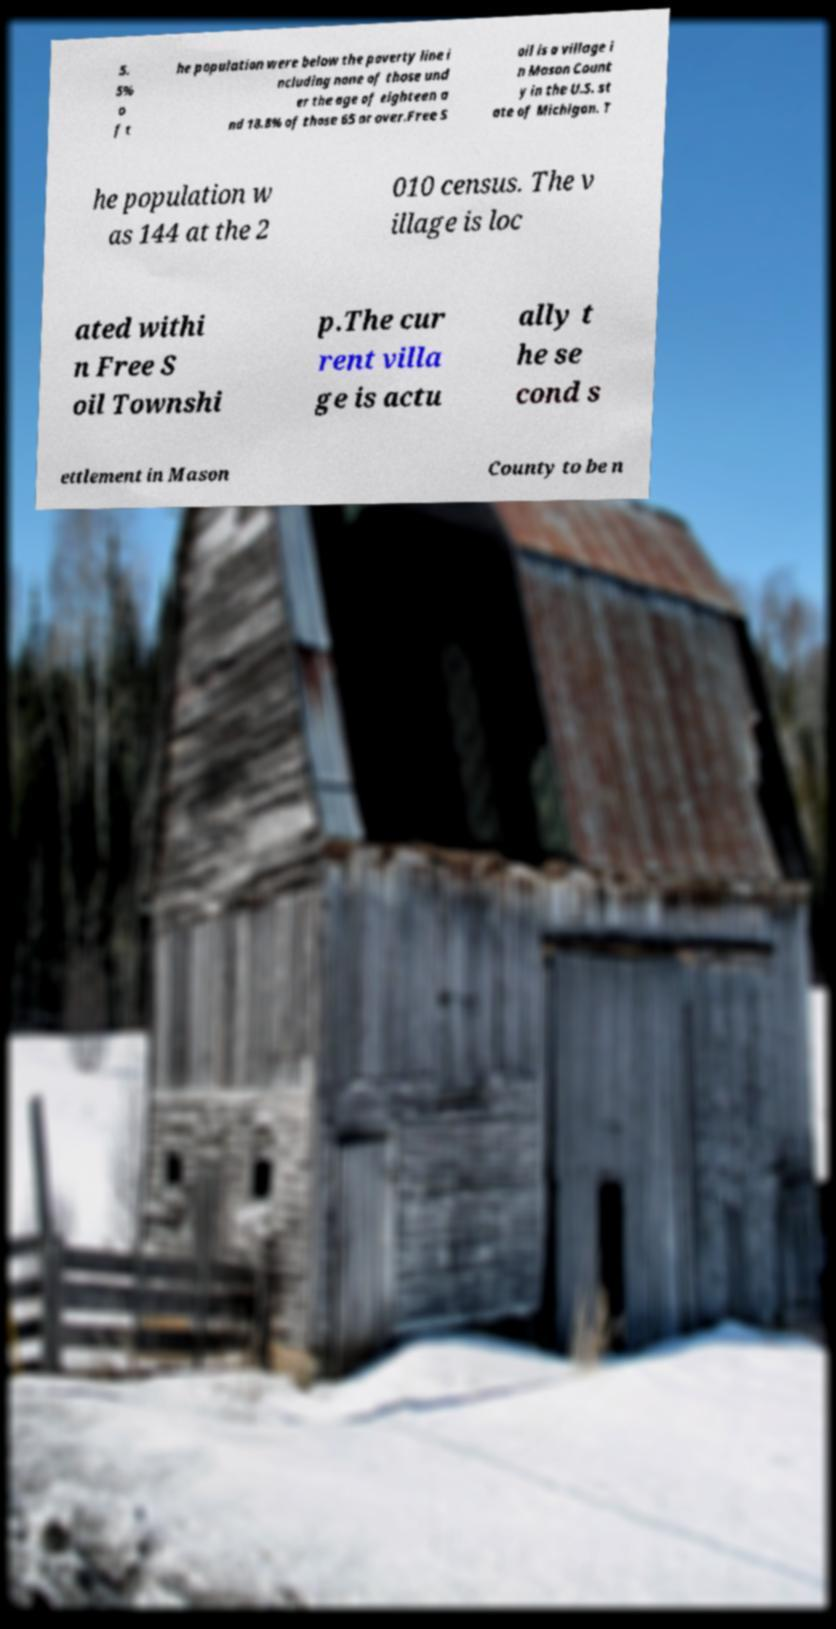I need the written content from this picture converted into text. Can you do that? 5. 5% o f t he population were below the poverty line i ncluding none of those und er the age of eighteen a nd 18.8% of those 65 or over.Free S oil is a village i n Mason Count y in the U.S. st ate of Michigan. T he population w as 144 at the 2 010 census. The v illage is loc ated withi n Free S oil Townshi p.The cur rent villa ge is actu ally t he se cond s ettlement in Mason County to be n 